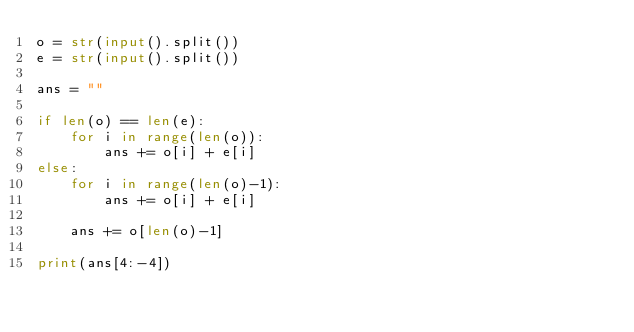Convert code to text. <code><loc_0><loc_0><loc_500><loc_500><_Python_>o = str(input().split())
e = str(input().split())

ans = ""

if len(o) == len(e):
    for i in range(len(o)):
        ans += o[i] + e[i]
else:
    for i in range(len(o)-1):
        ans += o[i] + e[i]
    
    ans += o[len(o)-1]

print(ans[4:-4])</code> 